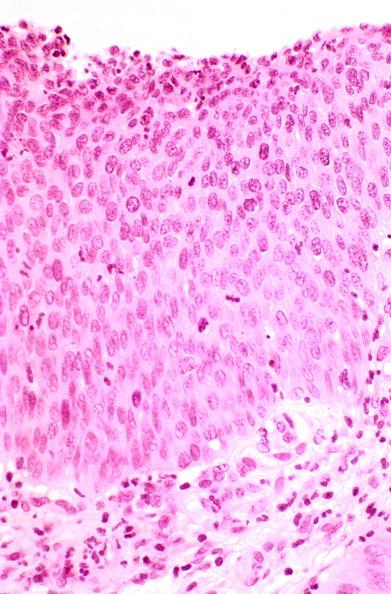does fallopian tube show cervix, severe dysplasia to carcinoma in situ?
Answer the question using a single word or phrase. No 